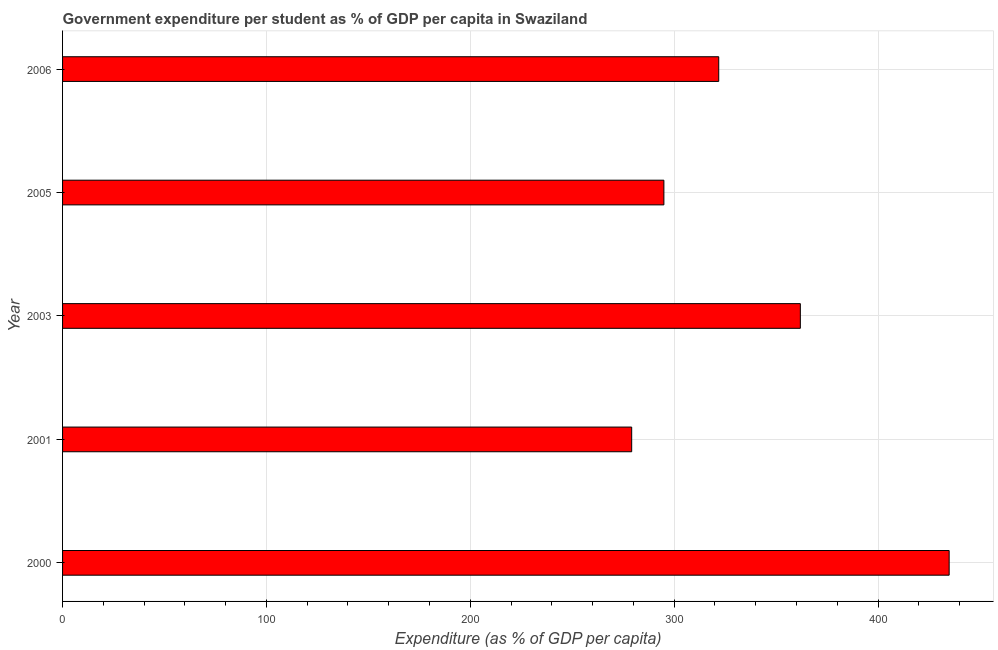Does the graph contain any zero values?
Make the answer very short. No. Does the graph contain grids?
Keep it short and to the point. Yes. What is the title of the graph?
Your response must be concise. Government expenditure per student as % of GDP per capita in Swaziland. What is the label or title of the X-axis?
Keep it short and to the point. Expenditure (as % of GDP per capita). What is the government expenditure per student in 2001?
Give a very brief answer. 279.15. Across all years, what is the maximum government expenditure per student?
Ensure brevity in your answer.  434.87. Across all years, what is the minimum government expenditure per student?
Offer a very short reply. 279.15. In which year was the government expenditure per student minimum?
Provide a short and direct response. 2001. What is the sum of the government expenditure per student?
Your answer should be very brief. 1692.7. What is the difference between the government expenditure per student in 2001 and 2003?
Offer a terse response. -82.72. What is the average government expenditure per student per year?
Your answer should be very brief. 338.54. What is the median government expenditure per student?
Your answer should be compact. 321.85. In how many years, is the government expenditure per student greater than 420 %?
Provide a succinct answer. 1. What is the ratio of the government expenditure per student in 2001 to that in 2006?
Ensure brevity in your answer.  0.87. Is the government expenditure per student in 2000 less than that in 2006?
Your response must be concise. No. What is the difference between the highest and the second highest government expenditure per student?
Provide a succinct answer. 73. What is the difference between the highest and the lowest government expenditure per student?
Provide a succinct answer. 155.72. Are all the bars in the graph horizontal?
Your answer should be very brief. Yes. What is the difference between two consecutive major ticks on the X-axis?
Provide a succinct answer. 100. What is the Expenditure (as % of GDP per capita) of 2000?
Make the answer very short. 434.87. What is the Expenditure (as % of GDP per capita) of 2001?
Your answer should be compact. 279.15. What is the Expenditure (as % of GDP per capita) of 2003?
Your answer should be very brief. 361.88. What is the Expenditure (as % of GDP per capita) of 2005?
Your response must be concise. 294.95. What is the Expenditure (as % of GDP per capita) of 2006?
Your answer should be compact. 321.85. What is the difference between the Expenditure (as % of GDP per capita) in 2000 and 2001?
Your answer should be very brief. 155.72. What is the difference between the Expenditure (as % of GDP per capita) in 2000 and 2003?
Ensure brevity in your answer.  72.99. What is the difference between the Expenditure (as % of GDP per capita) in 2000 and 2005?
Your response must be concise. 139.92. What is the difference between the Expenditure (as % of GDP per capita) in 2000 and 2006?
Provide a succinct answer. 113.02. What is the difference between the Expenditure (as % of GDP per capita) in 2001 and 2003?
Keep it short and to the point. -82.72. What is the difference between the Expenditure (as % of GDP per capita) in 2001 and 2005?
Ensure brevity in your answer.  -15.8. What is the difference between the Expenditure (as % of GDP per capita) in 2001 and 2006?
Offer a very short reply. -42.7. What is the difference between the Expenditure (as % of GDP per capita) in 2003 and 2005?
Your answer should be compact. 66.93. What is the difference between the Expenditure (as % of GDP per capita) in 2003 and 2006?
Make the answer very short. 40.03. What is the difference between the Expenditure (as % of GDP per capita) in 2005 and 2006?
Offer a very short reply. -26.9. What is the ratio of the Expenditure (as % of GDP per capita) in 2000 to that in 2001?
Give a very brief answer. 1.56. What is the ratio of the Expenditure (as % of GDP per capita) in 2000 to that in 2003?
Provide a short and direct response. 1.2. What is the ratio of the Expenditure (as % of GDP per capita) in 2000 to that in 2005?
Give a very brief answer. 1.47. What is the ratio of the Expenditure (as % of GDP per capita) in 2000 to that in 2006?
Give a very brief answer. 1.35. What is the ratio of the Expenditure (as % of GDP per capita) in 2001 to that in 2003?
Provide a short and direct response. 0.77. What is the ratio of the Expenditure (as % of GDP per capita) in 2001 to that in 2005?
Provide a succinct answer. 0.95. What is the ratio of the Expenditure (as % of GDP per capita) in 2001 to that in 2006?
Your response must be concise. 0.87. What is the ratio of the Expenditure (as % of GDP per capita) in 2003 to that in 2005?
Give a very brief answer. 1.23. What is the ratio of the Expenditure (as % of GDP per capita) in 2003 to that in 2006?
Your answer should be very brief. 1.12. What is the ratio of the Expenditure (as % of GDP per capita) in 2005 to that in 2006?
Make the answer very short. 0.92. 